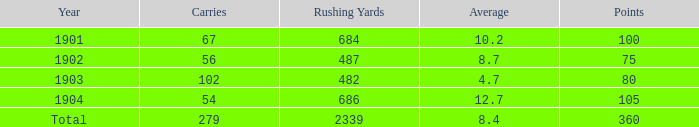4 and under 54 carries? 0.0. 